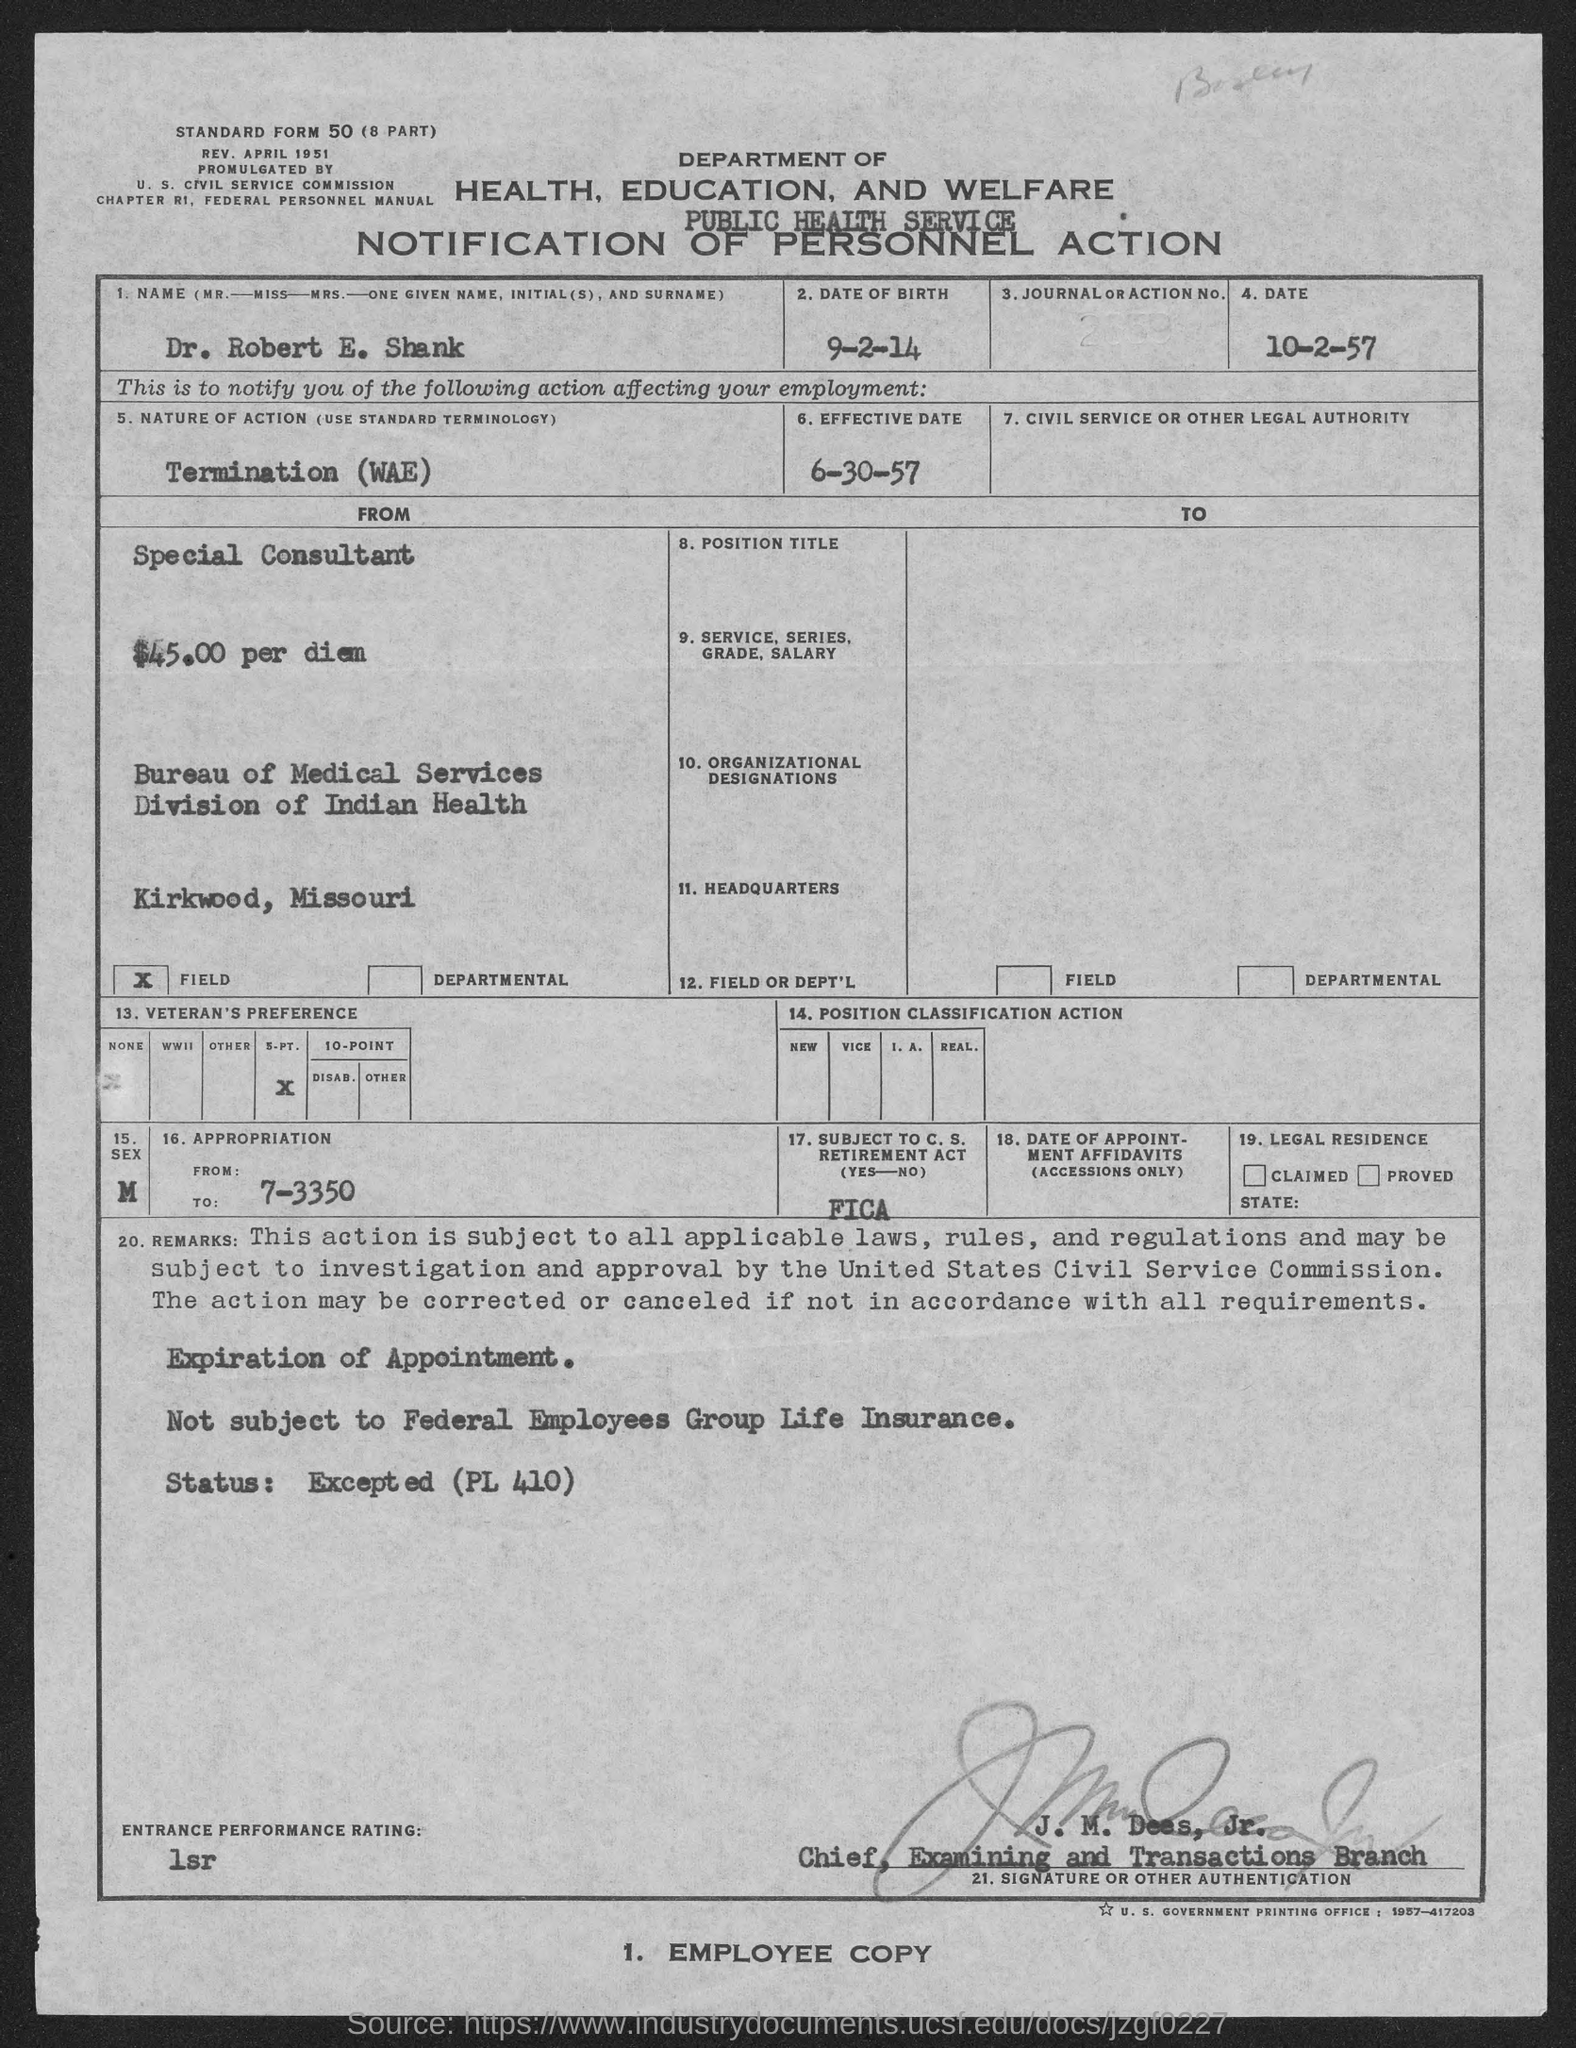Highlight a few significant elements in this photo. The effective date of June 30, 1957, has been established. The nature of action is determined by its termination. The candidate's name is Dr. Robert E. Shank. The date of birth is September 2, 2014. 